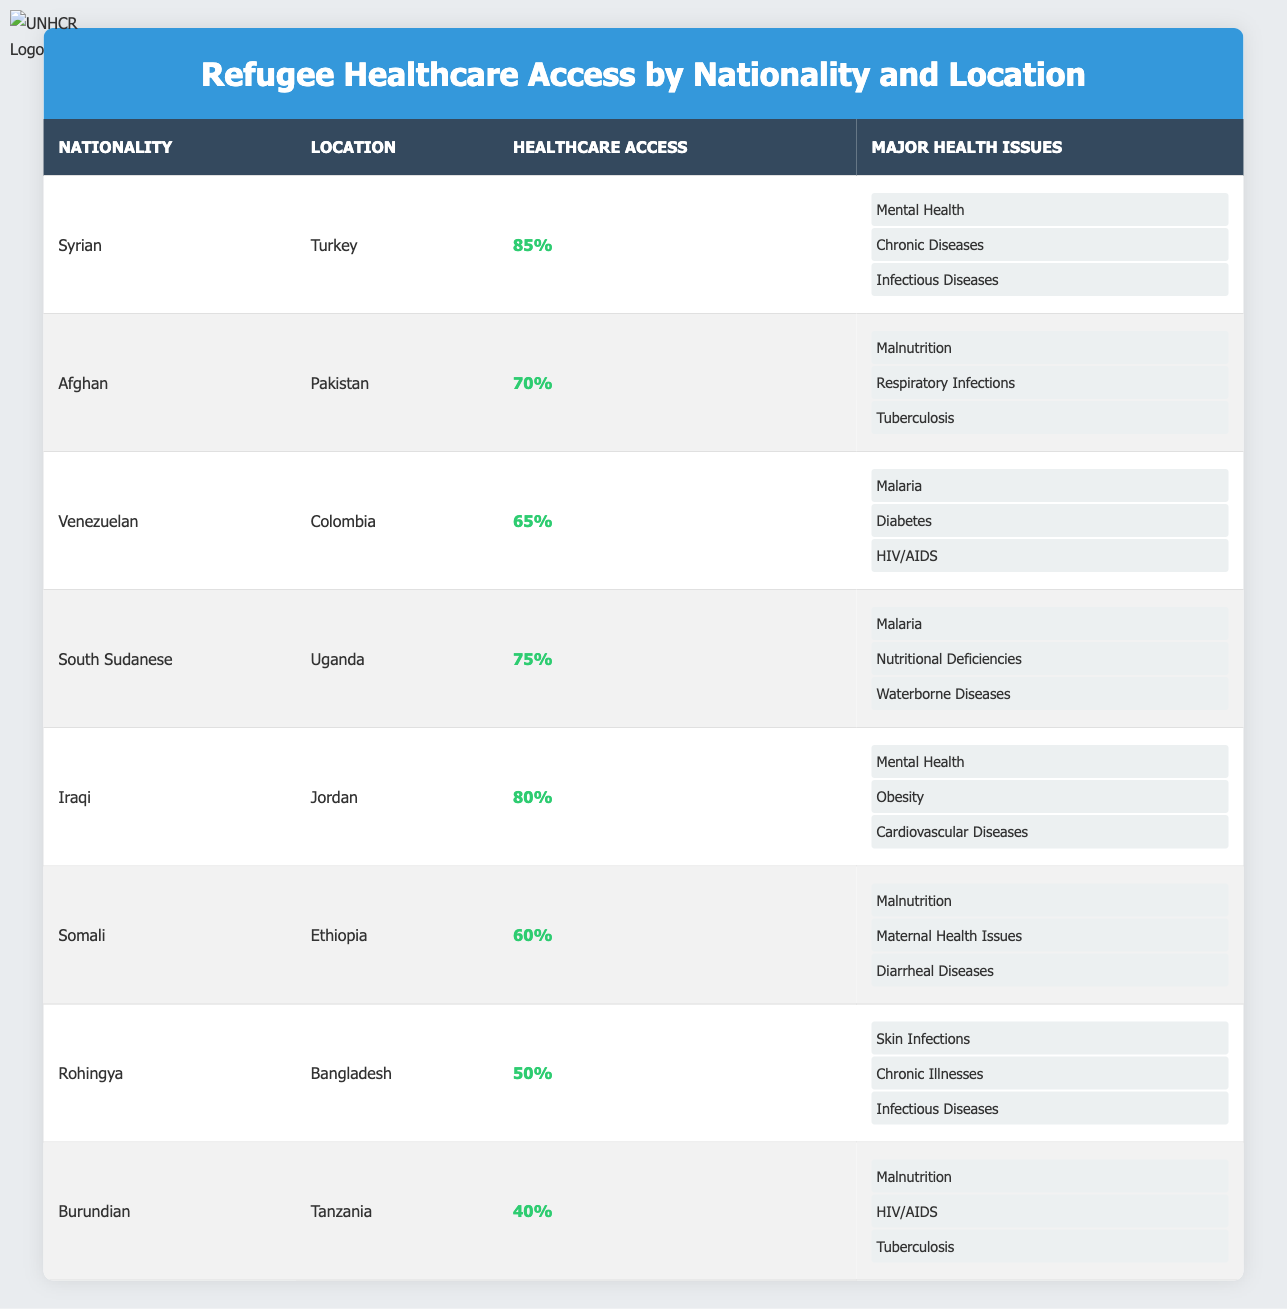What is the healthcare access percentage for Syrian refugees in Turkey? According to the table, Syrian refugees in Turkey have a healthcare access percentage of 85%.
Answer: 85% Which nationality has the lowest healthcare access percentage? The table shows that Burundian refugees in Tanzania have the lowest healthcare access percentage of 40%.
Answer: Burundian How many major health issues are listed for Afghan refugees in Pakistan? The table indicates that Afghan refugees in Pakistan have three major health issues: Malnutrition, Respiratory Infections, and Tuberculosis.
Answer: 3 What is the average healthcare access percentage for refugees from Iraq and South Sudan? The healthcare access percentage for Iraqi refugees is 80% and for South Sudanese is 75%, so the average is (80 + 75) / 2 = 77.5%.
Answer: 77.5% Do Venezuelan refugees in Colombia face chronic diseases as a major health issue? The table does not list chronic diseases among the major health issues for Venezuelan refugees; it instead cites Malaria, Diabetes, and HIV/AIDS.
Answer: No What is the total healthcare access percentage for refugees from Somalia and Rohingya combined? The healthcare access percentages for Somali refugees is 60% and for Rohingya is 50%. Adding these gives us 60 + 50 = 110%.
Answer: 110% Which refugee group has mental health issues as one of their major health challenges? The table indicates that both Syrian refugees in Turkey and Iraqi refugees in Jordan have mental health listed as a major health issue.
Answer: Syrian and Iraqi What is the difference in healthcare access percentage between South Sudanese refugees and Burundian refugees? South Sudanese refugees have a healthcare access percentage of 75%, while Burundian refugees have 40%. The difference is 75 - 40 = 35%.
Answer: 35% How many nationalities have a healthcare access percentage of less than 60%? The table shows that Rohingya with 50% and Burundian with 40% are the only two nationalities under 60%, thus there are 2 nationalities.
Answer: 2 